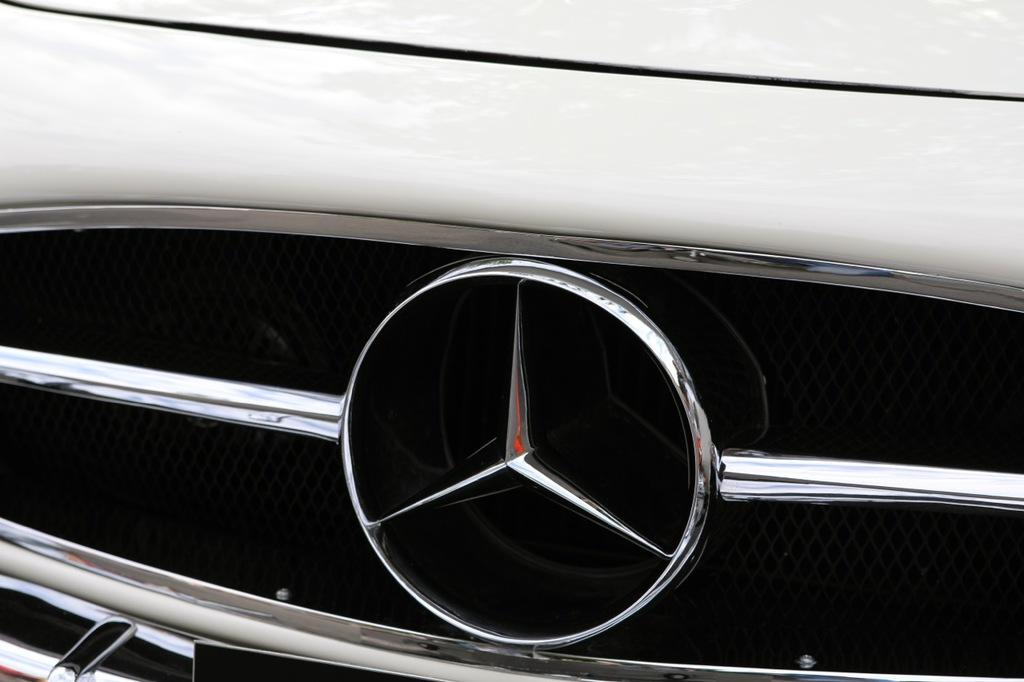What is the main subject of the image? The main subject of the image is a car. Is there any other car-related symbol or object in the image? Yes, there is a car symbol in the image. What type of sock is hanging from the car in the image? There is no sock present in the image; it only features a car and a car symbol. 